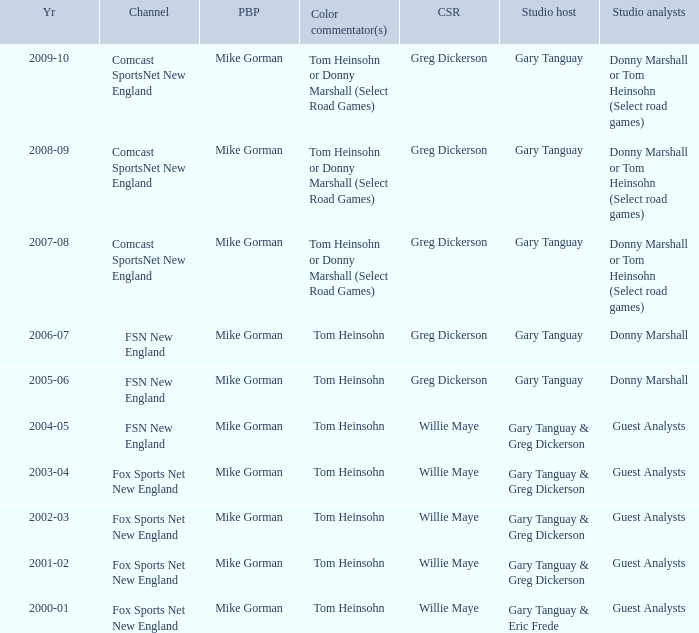WHich Studio analysts has a Studio host of gary tanguay in 2009-10? Donny Marshall or Tom Heinsohn (Select road games). 